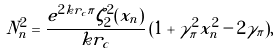<formula> <loc_0><loc_0><loc_500><loc_500>N _ { n } ^ { 2 } = \frac { e ^ { 2 k r _ { c } \pi } \zeta _ { 2 } ^ { 2 } ( x _ { n } ) } { k r _ { c } } \, ( 1 + \gamma _ { \pi } ^ { 2 } x _ { n } ^ { 2 } - 2 \gamma _ { \pi } ) ,</formula> 